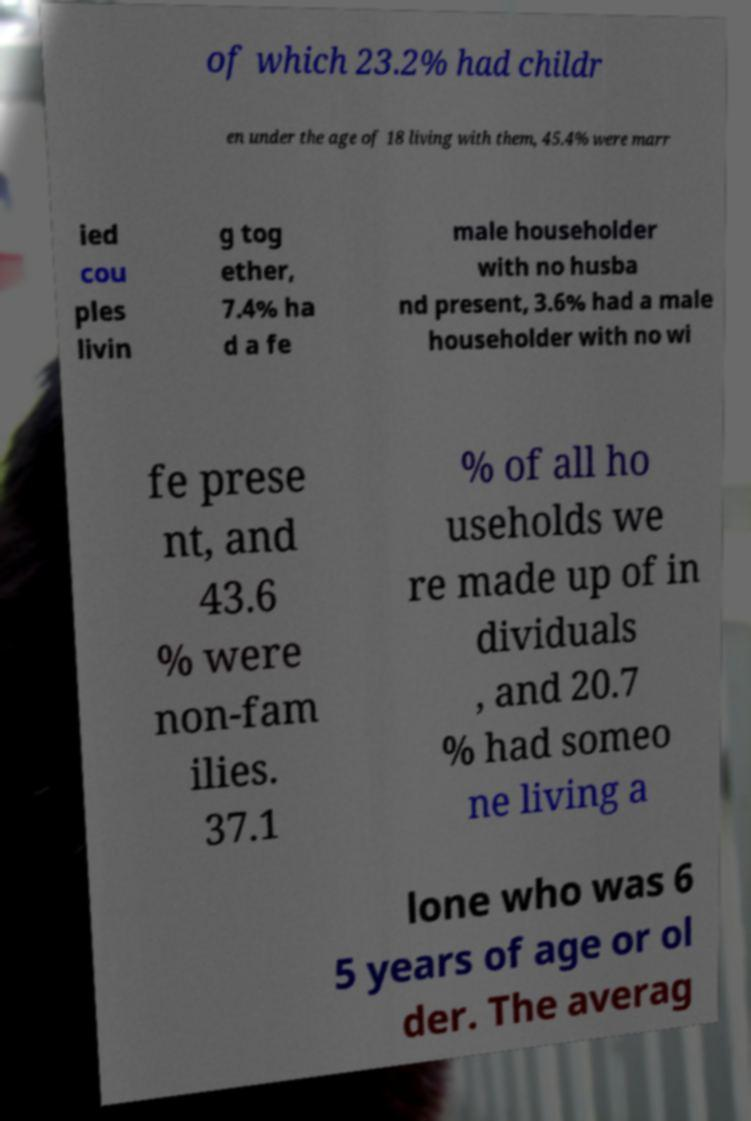Could you extract and type out the text from this image? of which 23.2% had childr en under the age of 18 living with them, 45.4% were marr ied cou ples livin g tog ether, 7.4% ha d a fe male householder with no husba nd present, 3.6% had a male householder with no wi fe prese nt, and 43.6 % were non-fam ilies. 37.1 % of all ho useholds we re made up of in dividuals , and 20.7 % had someo ne living a lone who was 6 5 years of age or ol der. The averag 